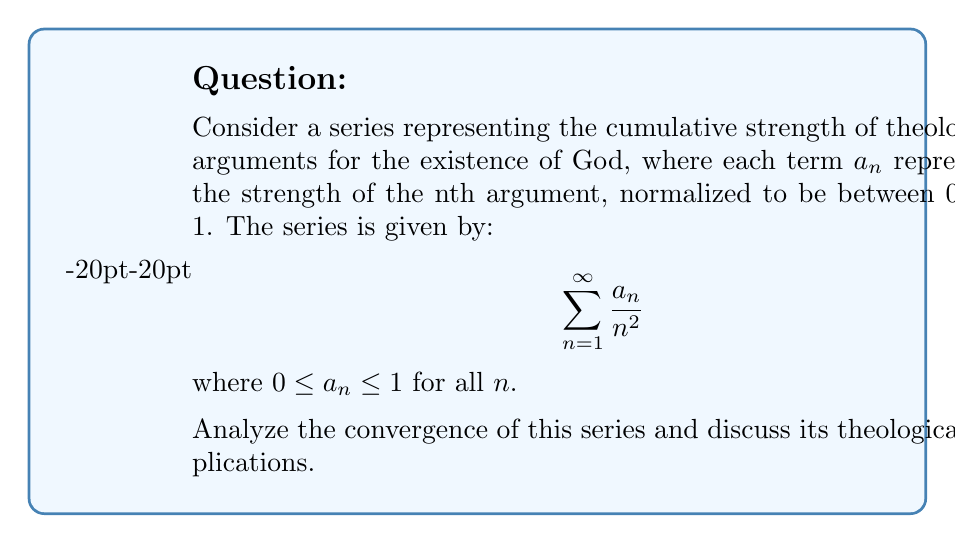Help me with this question. To analyze the convergence of this series, we'll use the comparison test:

1) First, note that $0 \leq a_n \leq 1$ for all $n$, so:

   $$0 \leq \frac{a_n}{n^2} \leq \frac{1}{n^2}$$

2) We know that the series $\sum_{n=1}^{\infty} \frac{1}{n^2}$ is the p-series with p=2, which converges (it's actually equal to $\frac{\pi^2}{6}$).

3) By the comparison test, since $0 \leq \frac{a_n}{n^2} \leq \frac{1}{n^2}$ for all $n$, and $\sum_{n=1}^{\infty} \frac{1}{n^2}$ converges, our series $\sum_{n=1}^{\infty} \frac{a_n}{n^2}$ must also converge.

4) The convergence of this series implies that the sum of the strengths of all theological arguments, when weighted by $\frac{1}{n^2}$, is finite.

5) Theologically, this could be interpreted as suggesting that while there may be infinitely many arguments for the existence of God, their cumulative strength (when properly weighted) does not become arbitrarily large.

6) The $\frac{1}{n^2}$ factor could be seen as representing the diminishing returns of additional arguments, reflecting the idea that after a certain point, new arguments add less to the overall case.

7) The convergence also implies that the strength of individual arguments ($a_n$) must generally decrease faster than $n^2$ increases, or at least not increase too quickly, for the series to remain convergent.
Answer: The series converges by the comparison test with $\sum_{n=1}^{\infty} \frac{1}{n^2}$. 